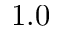<formula> <loc_0><loc_0><loc_500><loc_500>1 . 0</formula> 